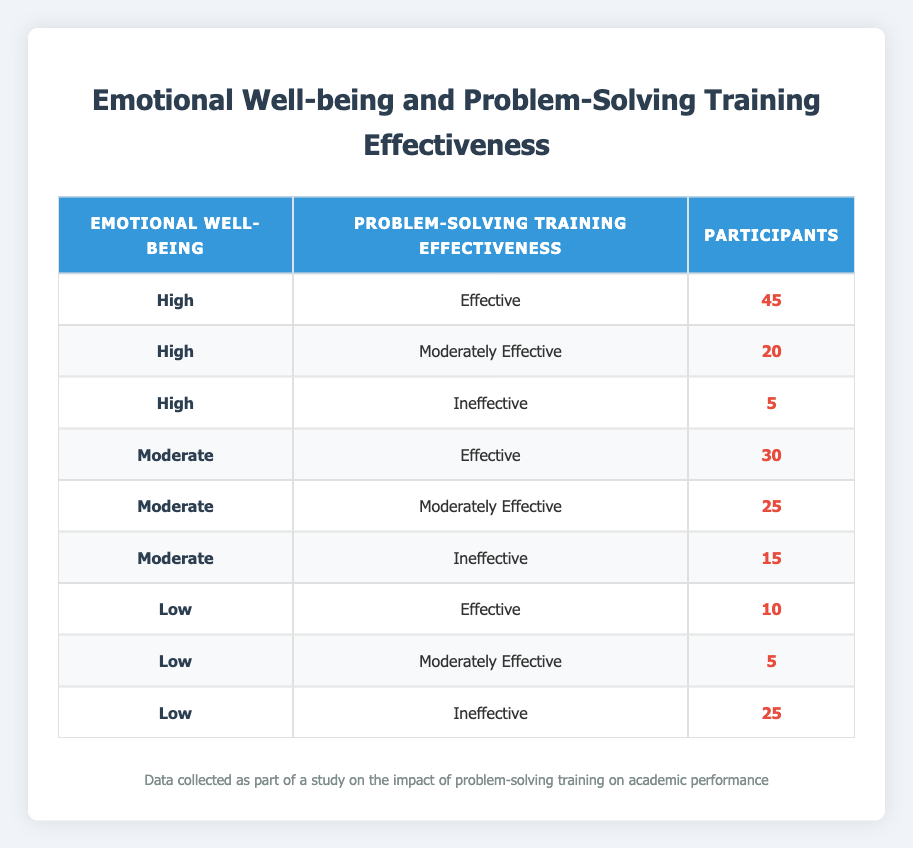What is the total number of participants with high emotional well-being? The rows that show "High" in the Emotional Well-being column are: Effective (45), Moderately Effective (20), and Ineffective (5). Adding these together gives: 45 + 20 + 5 = 70.
Answer: 70 How many participants found the problem-solving training to be ineffective when their emotional well-being was low? There is one row for participants with low emotional well-being labeled "Ineffective," which shows 25 participants.
Answer: 25 What is the average number of participants for each level of emotional well-being? The number of participants for each level is High (70), Moderate (70), and Low (40). Calculating the average: (70 + 70 + 40) / 3 = 60.
Answer: 60 Is it true that more participants with high emotional well-being rated the training as effective than those with low emotional well-being? High emotional well-being effective participants: 45; Low emotional well-being effective participants: 10. Since 45 is greater than 10, the statement is true.
Answer: Yes What is the difference in the number of participants rating the training as moderately effective between those with moderate and high emotional well-being? For high, there are 20 participants who rated it as moderately effective; for moderate, there are 25 participants. The difference is 25 - 20 = 5.
Answer: 5 How many total participants rated the problem-solving training as effective across all emotional well-being levels? Participants who rated it as effective are from High (45), Moderate (30), and Low (10). Adding these gives 45 + 30 + 10 = 85.
Answer: 85 What percentage of participants with moderate emotional well-being found the training ineffective? The ineffective participants with moderate emotional well-being are 15 out of a total of 70 (30 effective + 25 moderately effective + 15 ineffective). The percentage calculation is (15 / 70) * 100 = 21.43%.
Answer: 21.43% How many participants in total are there with moderate emotional well-being? For moderate emotional well-being, the rows are Effective (30), Moderately Effective (25), and Ineffective (15). Adding these together gives 30 + 25 + 15 = 70.
Answer: 70 